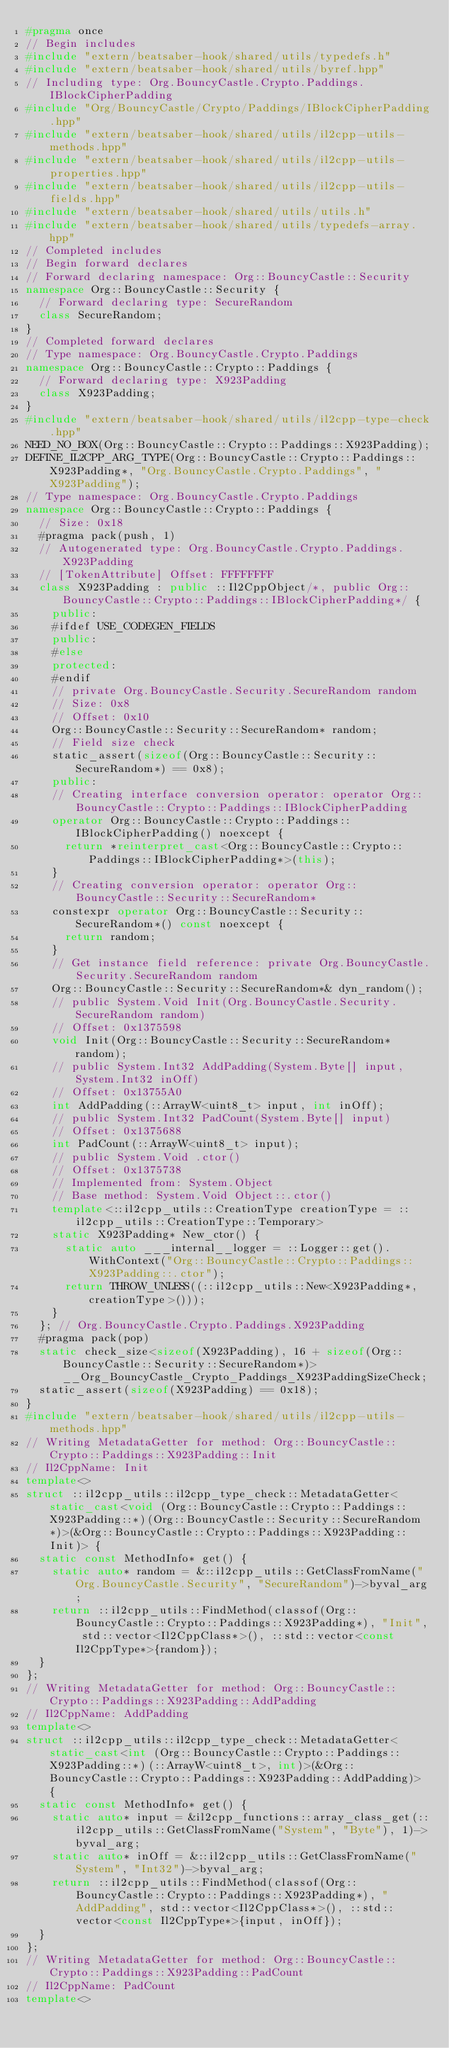<code> <loc_0><loc_0><loc_500><loc_500><_C++_>#pragma once
// Begin includes
#include "extern/beatsaber-hook/shared/utils/typedefs.h"
#include "extern/beatsaber-hook/shared/utils/byref.hpp"
// Including type: Org.BouncyCastle.Crypto.Paddings.IBlockCipherPadding
#include "Org/BouncyCastle/Crypto/Paddings/IBlockCipherPadding.hpp"
#include "extern/beatsaber-hook/shared/utils/il2cpp-utils-methods.hpp"
#include "extern/beatsaber-hook/shared/utils/il2cpp-utils-properties.hpp"
#include "extern/beatsaber-hook/shared/utils/il2cpp-utils-fields.hpp"
#include "extern/beatsaber-hook/shared/utils/utils.h"
#include "extern/beatsaber-hook/shared/utils/typedefs-array.hpp"
// Completed includes
// Begin forward declares
// Forward declaring namespace: Org::BouncyCastle::Security
namespace Org::BouncyCastle::Security {
  // Forward declaring type: SecureRandom
  class SecureRandom;
}
// Completed forward declares
// Type namespace: Org.BouncyCastle.Crypto.Paddings
namespace Org::BouncyCastle::Crypto::Paddings {
  // Forward declaring type: X923Padding
  class X923Padding;
}
#include "extern/beatsaber-hook/shared/utils/il2cpp-type-check.hpp"
NEED_NO_BOX(Org::BouncyCastle::Crypto::Paddings::X923Padding);
DEFINE_IL2CPP_ARG_TYPE(Org::BouncyCastle::Crypto::Paddings::X923Padding*, "Org.BouncyCastle.Crypto.Paddings", "X923Padding");
// Type namespace: Org.BouncyCastle.Crypto.Paddings
namespace Org::BouncyCastle::Crypto::Paddings {
  // Size: 0x18
  #pragma pack(push, 1)
  // Autogenerated type: Org.BouncyCastle.Crypto.Paddings.X923Padding
  // [TokenAttribute] Offset: FFFFFFFF
  class X923Padding : public ::Il2CppObject/*, public Org::BouncyCastle::Crypto::Paddings::IBlockCipherPadding*/ {
    public:
    #ifdef USE_CODEGEN_FIELDS
    public:
    #else
    protected:
    #endif
    // private Org.BouncyCastle.Security.SecureRandom random
    // Size: 0x8
    // Offset: 0x10
    Org::BouncyCastle::Security::SecureRandom* random;
    // Field size check
    static_assert(sizeof(Org::BouncyCastle::Security::SecureRandom*) == 0x8);
    public:
    // Creating interface conversion operator: operator Org::BouncyCastle::Crypto::Paddings::IBlockCipherPadding
    operator Org::BouncyCastle::Crypto::Paddings::IBlockCipherPadding() noexcept {
      return *reinterpret_cast<Org::BouncyCastle::Crypto::Paddings::IBlockCipherPadding*>(this);
    }
    // Creating conversion operator: operator Org::BouncyCastle::Security::SecureRandom*
    constexpr operator Org::BouncyCastle::Security::SecureRandom*() const noexcept {
      return random;
    }
    // Get instance field reference: private Org.BouncyCastle.Security.SecureRandom random
    Org::BouncyCastle::Security::SecureRandom*& dyn_random();
    // public System.Void Init(Org.BouncyCastle.Security.SecureRandom random)
    // Offset: 0x1375598
    void Init(Org::BouncyCastle::Security::SecureRandom* random);
    // public System.Int32 AddPadding(System.Byte[] input, System.Int32 inOff)
    // Offset: 0x13755A0
    int AddPadding(::ArrayW<uint8_t> input, int inOff);
    // public System.Int32 PadCount(System.Byte[] input)
    // Offset: 0x1375688
    int PadCount(::ArrayW<uint8_t> input);
    // public System.Void .ctor()
    // Offset: 0x1375738
    // Implemented from: System.Object
    // Base method: System.Void Object::.ctor()
    template<::il2cpp_utils::CreationType creationType = ::il2cpp_utils::CreationType::Temporary>
    static X923Padding* New_ctor() {
      static auto ___internal__logger = ::Logger::get().WithContext("Org::BouncyCastle::Crypto::Paddings::X923Padding::.ctor");
      return THROW_UNLESS((::il2cpp_utils::New<X923Padding*, creationType>()));
    }
  }; // Org.BouncyCastle.Crypto.Paddings.X923Padding
  #pragma pack(pop)
  static check_size<sizeof(X923Padding), 16 + sizeof(Org::BouncyCastle::Security::SecureRandom*)> __Org_BouncyCastle_Crypto_Paddings_X923PaddingSizeCheck;
  static_assert(sizeof(X923Padding) == 0x18);
}
#include "extern/beatsaber-hook/shared/utils/il2cpp-utils-methods.hpp"
// Writing MetadataGetter for method: Org::BouncyCastle::Crypto::Paddings::X923Padding::Init
// Il2CppName: Init
template<>
struct ::il2cpp_utils::il2cpp_type_check::MetadataGetter<static_cast<void (Org::BouncyCastle::Crypto::Paddings::X923Padding::*)(Org::BouncyCastle::Security::SecureRandom*)>(&Org::BouncyCastle::Crypto::Paddings::X923Padding::Init)> {
  static const MethodInfo* get() {
    static auto* random = &::il2cpp_utils::GetClassFromName("Org.BouncyCastle.Security", "SecureRandom")->byval_arg;
    return ::il2cpp_utils::FindMethod(classof(Org::BouncyCastle::Crypto::Paddings::X923Padding*), "Init", std::vector<Il2CppClass*>(), ::std::vector<const Il2CppType*>{random});
  }
};
// Writing MetadataGetter for method: Org::BouncyCastle::Crypto::Paddings::X923Padding::AddPadding
// Il2CppName: AddPadding
template<>
struct ::il2cpp_utils::il2cpp_type_check::MetadataGetter<static_cast<int (Org::BouncyCastle::Crypto::Paddings::X923Padding::*)(::ArrayW<uint8_t>, int)>(&Org::BouncyCastle::Crypto::Paddings::X923Padding::AddPadding)> {
  static const MethodInfo* get() {
    static auto* input = &il2cpp_functions::array_class_get(::il2cpp_utils::GetClassFromName("System", "Byte"), 1)->byval_arg;
    static auto* inOff = &::il2cpp_utils::GetClassFromName("System", "Int32")->byval_arg;
    return ::il2cpp_utils::FindMethod(classof(Org::BouncyCastle::Crypto::Paddings::X923Padding*), "AddPadding", std::vector<Il2CppClass*>(), ::std::vector<const Il2CppType*>{input, inOff});
  }
};
// Writing MetadataGetter for method: Org::BouncyCastle::Crypto::Paddings::X923Padding::PadCount
// Il2CppName: PadCount
template<></code> 